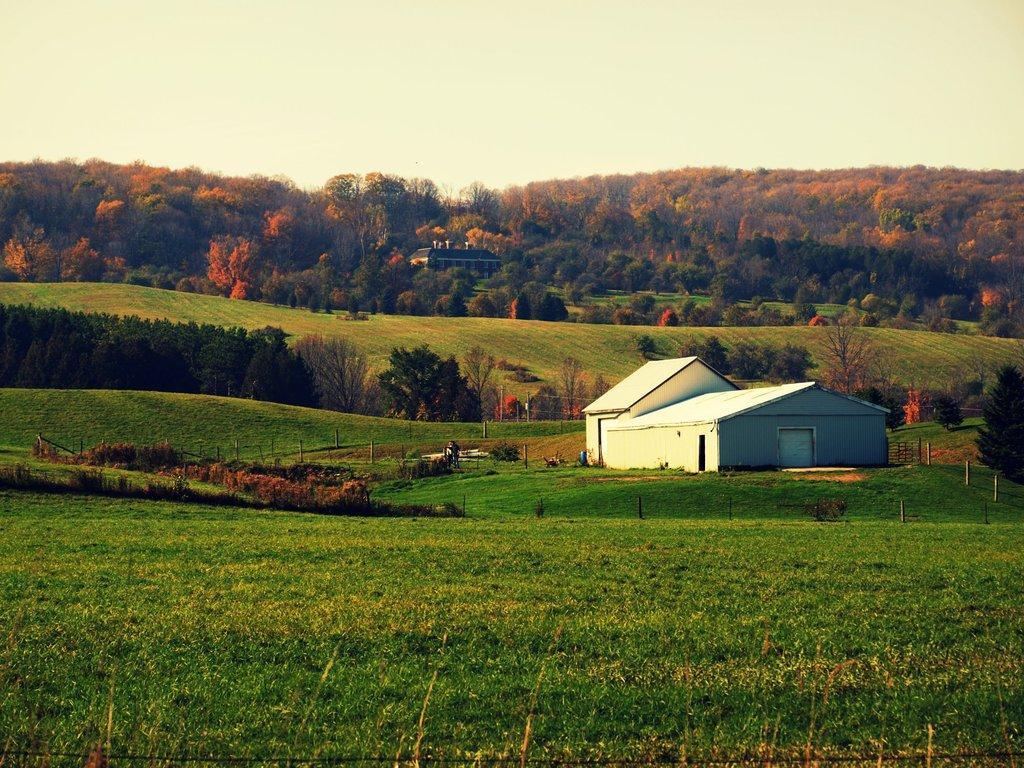In one or two sentences, can you explain what this image depicts? In this image, we can see some trees and plants. There is a shelter house in the middle of the image. There is a sky at the top of the image. 